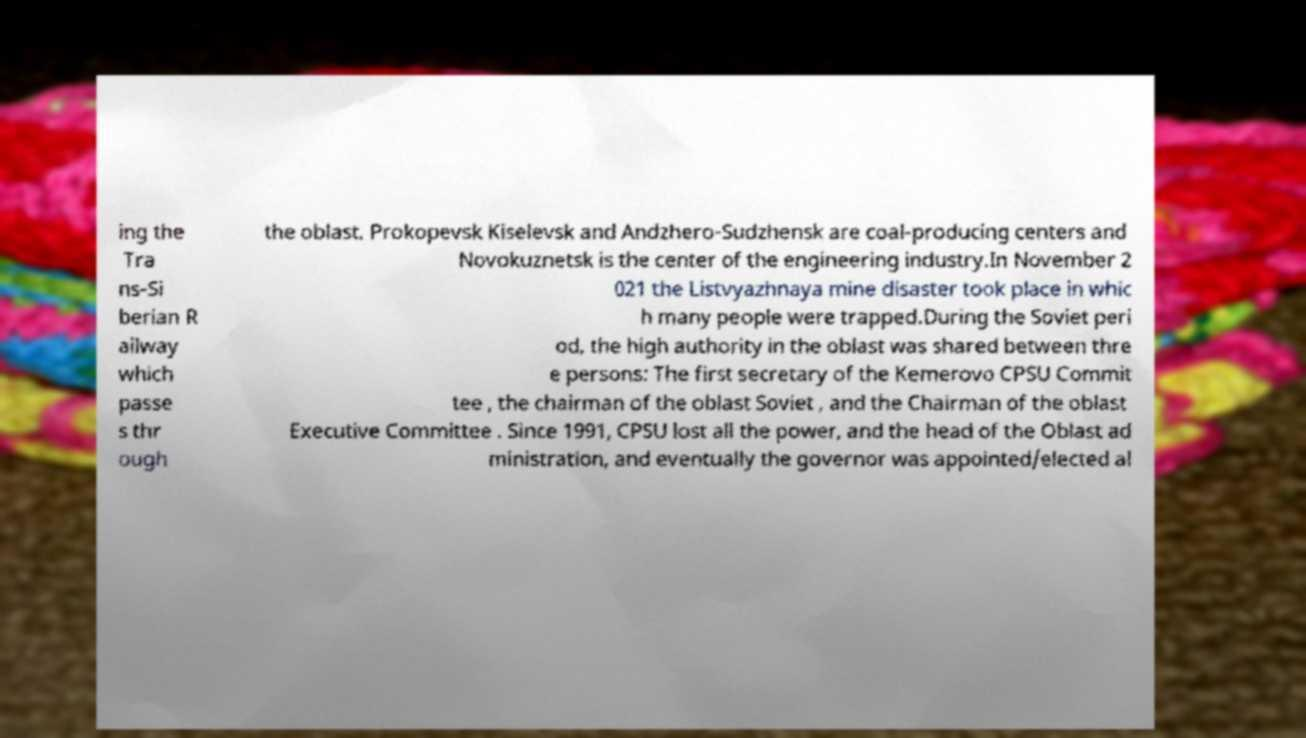Please identify and transcribe the text found in this image. ing the Tra ns-Si berian R ailway which passe s thr ough the oblast. Prokopevsk Kiselevsk and Andzhero-Sudzhensk are coal-producing centers and Novokuznetsk is the center of the engineering industry.In November 2 021 the Listvyazhnaya mine disaster took place in whic h many people were trapped.During the Soviet peri od, the high authority in the oblast was shared between thre e persons: The first secretary of the Kemerovo CPSU Commit tee , the chairman of the oblast Soviet , and the Chairman of the oblast Executive Committee . Since 1991, CPSU lost all the power, and the head of the Oblast ad ministration, and eventually the governor was appointed/elected al 